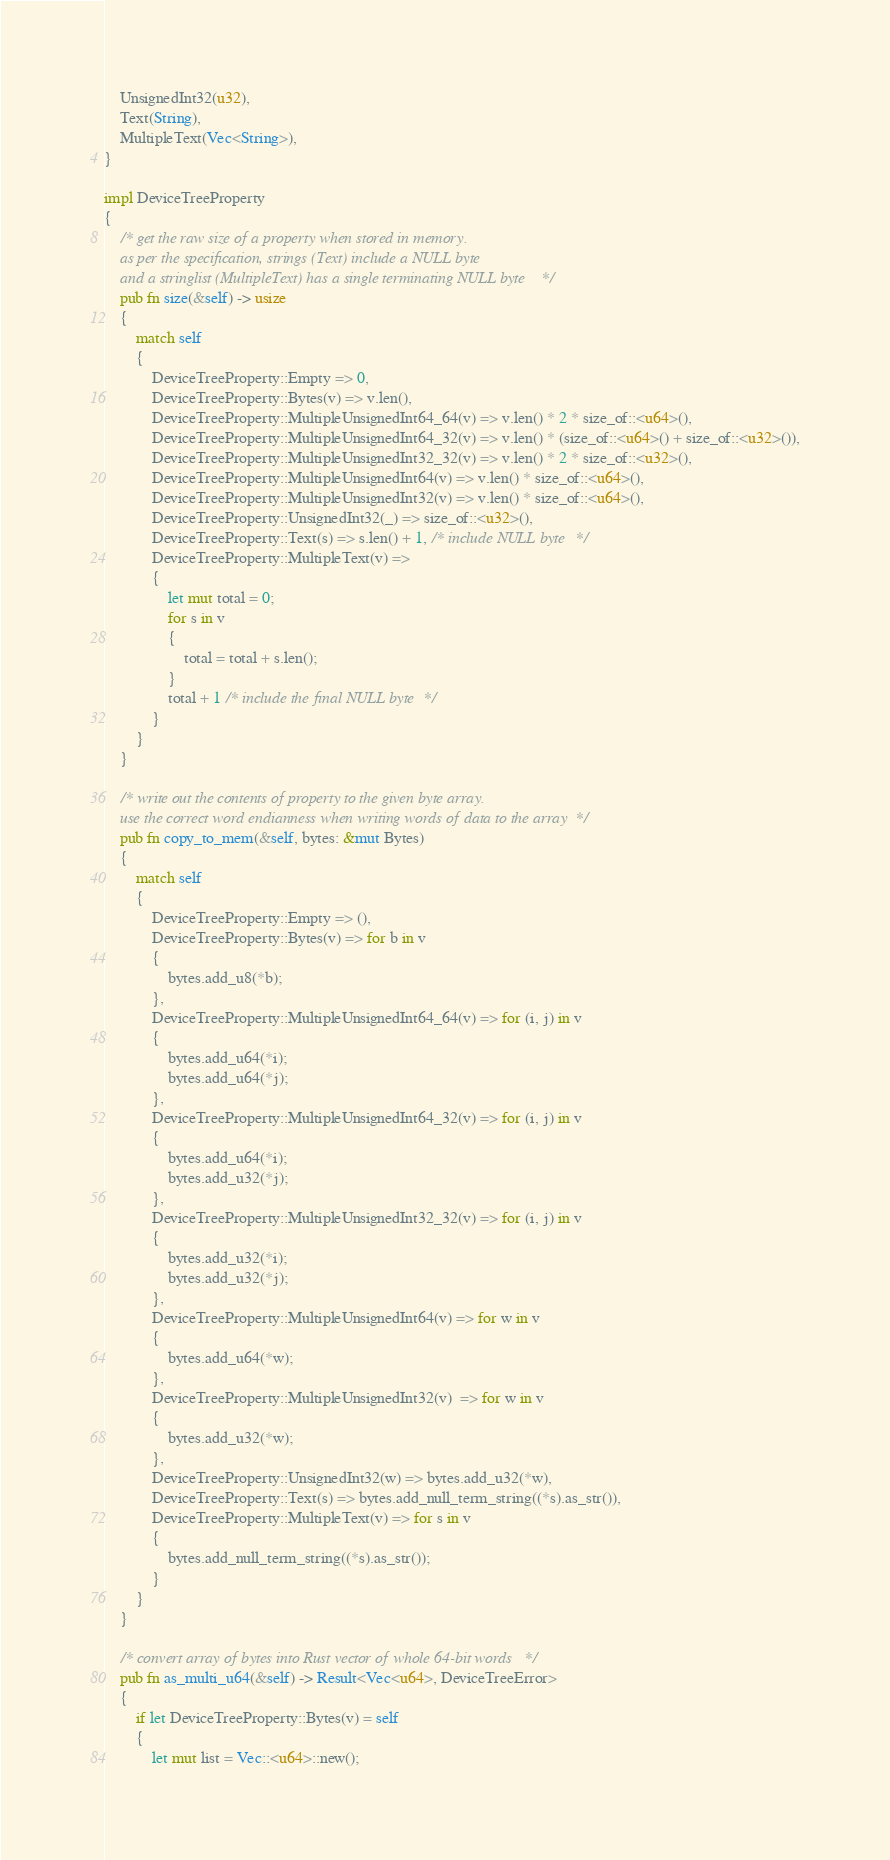<code> <loc_0><loc_0><loc_500><loc_500><_Rust_>
    UnsignedInt32(u32),
    Text(String),
    MultipleText(Vec<String>),
}

impl DeviceTreeProperty
{
    /* get the raw size of a property when stored in memory.
    as per the specification, strings (Text) include a NULL byte
    and a stringlist (MultipleText) has a single terminating NULL byte */
    pub fn size(&self) -> usize
    {
        match self
        {
            DeviceTreeProperty::Empty => 0,
            DeviceTreeProperty::Bytes(v) => v.len(),
            DeviceTreeProperty::MultipleUnsignedInt64_64(v) => v.len() * 2 * size_of::<u64>(),
            DeviceTreeProperty::MultipleUnsignedInt64_32(v) => v.len() * (size_of::<u64>() + size_of::<u32>()),
            DeviceTreeProperty::MultipleUnsignedInt32_32(v) => v.len() * 2 * size_of::<u32>(),
            DeviceTreeProperty::MultipleUnsignedInt64(v) => v.len() * size_of::<u64>(),
            DeviceTreeProperty::MultipleUnsignedInt32(v) => v.len() * size_of::<u64>(),
            DeviceTreeProperty::UnsignedInt32(_) => size_of::<u32>(),
            DeviceTreeProperty::Text(s) => s.len() + 1, /* include NULL byte */
            DeviceTreeProperty::MultipleText(v) =>
            {
                let mut total = 0;
                for s in v
                {
                    total = total + s.len();
                }
                total + 1 /* include the final NULL byte */
            }
        }
    }

    /* write out the contents of property to the given byte array.
    use the correct word endianness when writing words of data to the array */
    pub fn copy_to_mem(&self, bytes: &mut Bytes)
    {
        match self
        {
            DeviceTreeProperty::Empty => (),
            DeviceTreeProperty::Bytes(v) => for b in v
            {
                bytes.add_u8(*b);
            },
            DeviceTreeProperty::MultipleUnsignedInt64_64(v) => for (i, j) in v
            {
                bytes.add_u64(*i);
                bytes.add_u64(*j);
            },
            DeviceTreeProperty::MultipleUnsignedInt64_32(v) => for (i, j) in v
            {
                bytes.add_u64(*i);
                bytes.add_u32(*j);
            },
            DeviceTreeProperty::MultipleUnsignedInt32_32(v) => for (i, j) in v
            {
                bytes.add_u32(*i);
                bytes.add_u32(*j);
            },
            DeviceTreeProperty::MultipleUnsignedInt64(v) => for w in v
            {
                bytes.add_u64(*w);
            },
            DeviceTreeProperty::MultipleUnsignedInt32(v)  => for w in v
            {
                bytes.add_u32(*w);
            },
            DeviceTreeProperty::UnsignedInt32(w) => bytes.add_u32(*w),
            DeviceTreeProperty::Text(s) => bytes.add_null_term_string((*s).as_str()),
            DeviceTreeProperty::MultipleText(v) => for s in v
            {
                bytes.add_null_term_string((*s).as_str());
            }
        }
    }

    /* convert array of bytes into Rust vector of whole 64-bit words */
    pub fn as_multi_u64(&self) -> Result<Vec<u64>, DeviceTreeError>
    {
        if let DeviceTreeProperty::Bytes(v) = self
        {
            let mut list = Vec::<u64>::new();</code> 